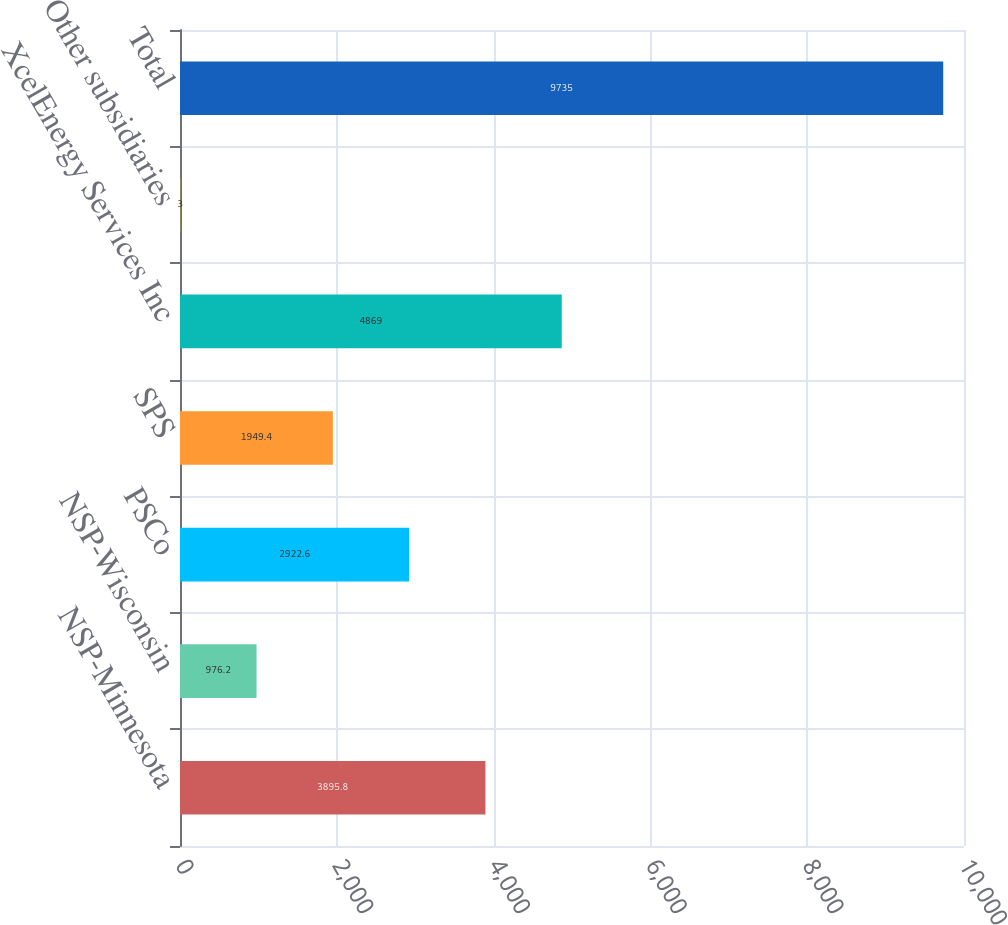Convert chart to OTSL. <chart><loc_0><loc_0><loc_500><loc_500><bar_chart><fcel>NSP-Minnesota<fcel>NSP-Wisconsin<fcel>PSCo<fcel>SPS<fcel>XcelEnergy Services Inc<fcel>Other subsidiaries<fcel>Total<nl><fcel>3895.8<fcel>976.2<fcel>2922.6<fcel>1949.4<fcel>4869<fcel>3<fcel>9735<nl></chart> 